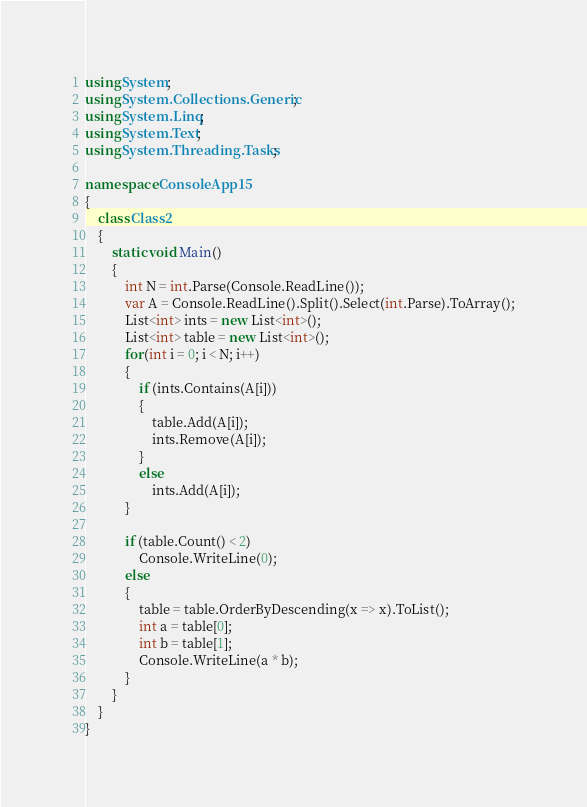<code> <loc_0><loc_0><loc_500><loc_500><_C#_>using System;
using System.Collections.Generic;
using System.Linq;
using System.Text;
using System.Threading.Tasks;

namespace ConsoleApp15
{
    class Class2
    {
        static void Main()
        {
            int N = int.Parse(Console.ReadLine());
            var A = Console.ReadLine().Split().Select(int.Parse).ToArray();
            List<int> ints = new List<int>();
            List<int> table = new List<int>();
            for(int i = 0; i < N; i++)
            {
                if (ints.Contains(A[i]))
                {
                    table.Add(A[i]);
                    ints.Remove(A[i]);
                }
                else
                    ints.Add(A[i]);
            }

            if (table.Count() < 2)
                Console.WriteLine(0);
            else
            {
                table = table.OrderByDescending(x => x).ToList();
                int a = table[0];
                int b = table[1];
                Console.WriteLine(a * b);
            }
        }
    }
}
</code> 